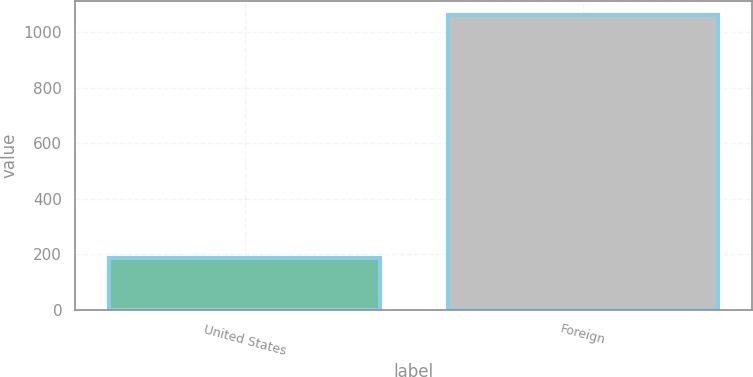<chart> <loc_0><loc_0><loc_500><loc_500><bar_chart><fcel>United States<fcel>Foreign<nl><fcel>188<fcel>1062<nl></chart> 